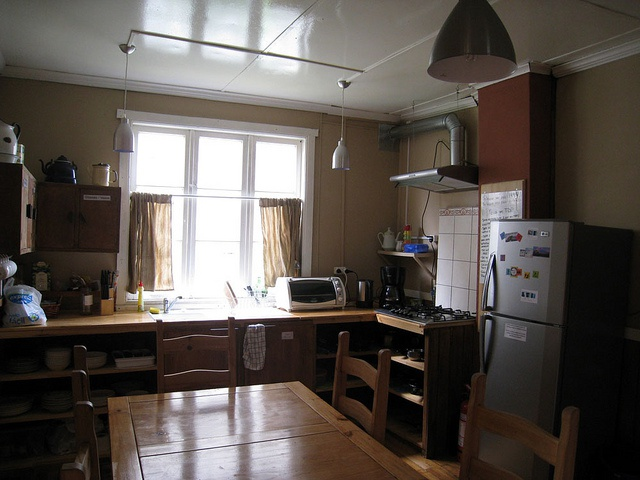Describe the objects in this image and their specific colors. I can see refrigerator in gray, black, and darkgray tones, dining table in gray, lightgray, darkgray, and maroon tones, chair in gray, black, and maroon tones, chair in gray and black tones, and chair in gray, black, and maroon tones in this image. 